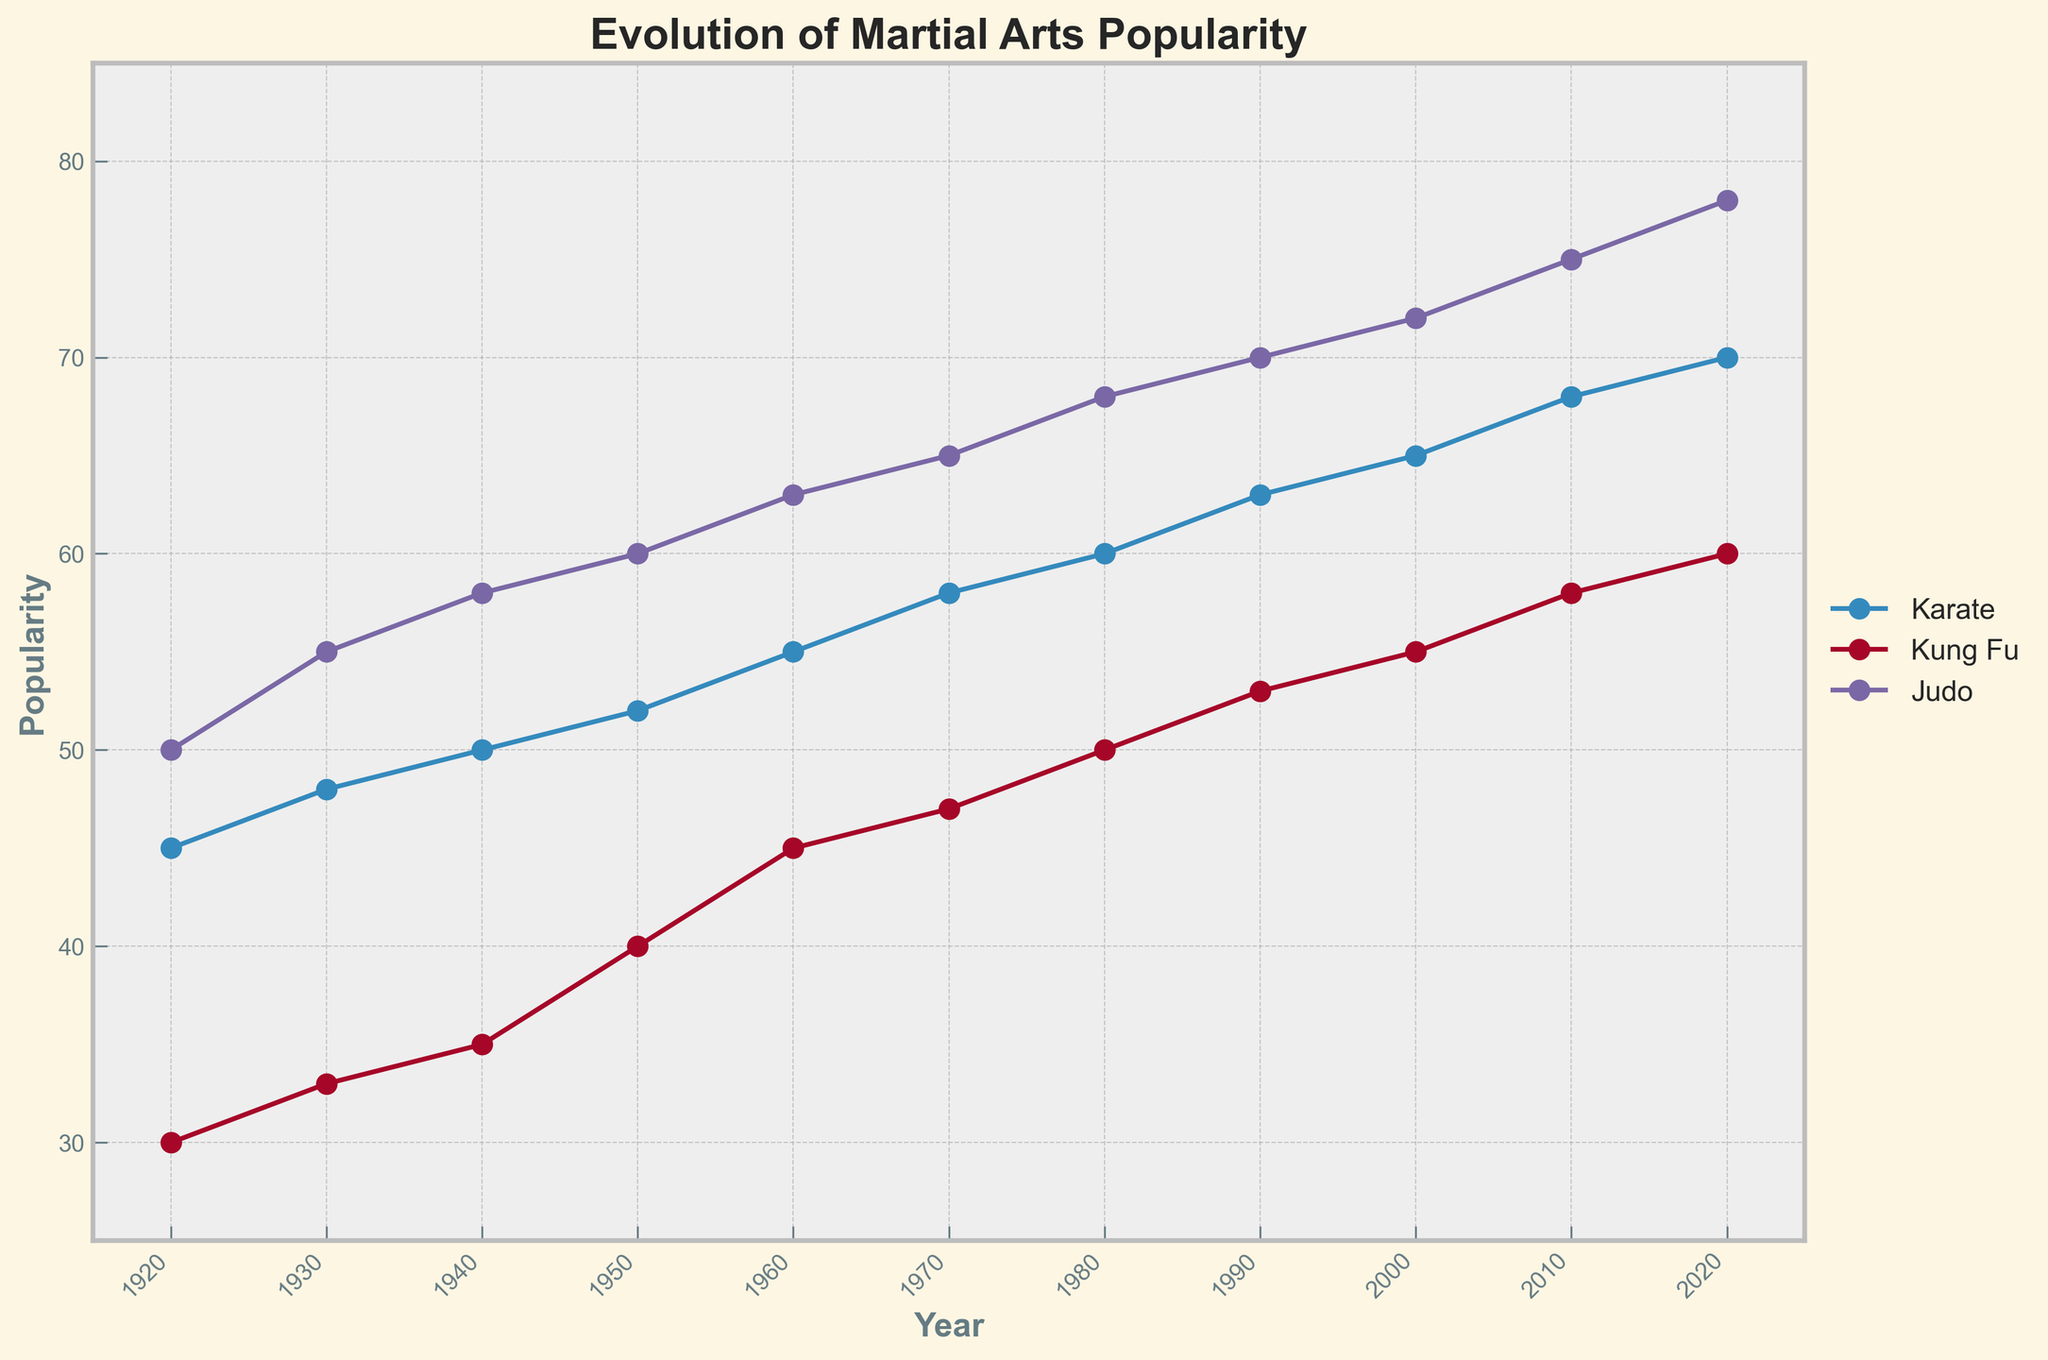What is the title of the plot? The title of the plot is located at the top and is a central, bold text. In the provided plot, the title is "Evolution of Martial Arts Popularity".
Answer: Evolution of Martial Arts Popularity Which martial art had the highest popularity in 2020? To find this, locate the year 2020 on the x-axis and identify the martial arts plotted for that year. Then, compare their popularity values. Judo (Kodokan) has the highest popularity with a value of 78.
Answer: Judo (Kodokan) How many different martial arts styles are represented in the year 1960? Look at the year 1960 along the x-axis and count the different markers representing different martial arts styles. There are three distinct styles: Karate (Kyokushin), Kung Fu (Baguazhang), and Judo (Kodokan).
Answer: Three Which martial art showed the greatest increase in popularity between 2000 and 2010? Compare the popularity values of all martial arts from 2000 to 2010. The difference in Judo (Kodokan) is (75 - 72) = 3, Karate (Shito-Ryu) is (68 - 65) = 3, and Kung Fu (Jeet Kune Do to Sanda) decreased. So the increase is the same for Judo and Karate.
Answer: Judo (Kodokan) and Karate (Shito-Ryu) What is the overall trend of judo's popularity from 1920 to 2020? To analyze the trend, track the popularity values for judo across the years. The data points show a consistently increasing trend from 50 in 1920 to 78 in 2020.
Answer: Increasing By how much did Karate (Shotokan) increase in popularity between 1920 and 1940? Look at the popularity values for Karate (Shotokan) in 1920 and 1940. The values are 45 and 50, respectively. The increase is 50 - 45 = 5.
Answer: 5 Which martial art saw a continuous rise in popularity across all data points from 1920 to 2020? Check each martial art's trend line from 1920 to 2020. Judo's (Kodokan) popularity continuously rises from 50 in 1920 to 78 in 2020.
Answer: Judo (Kodokan) At which point in time did Kung Fu's represented styles see the highest combined popularity? Add the popularity values for all Kung Fu styles at each decade. In 2010, the combined popularity of Kung Fu (Sanda) is 58, which is the highest among all specified years.
Answer: 2010 What was the popularity change for Kung Fu from 1980 to 1990? Find the popularity values for Kung Fu in 1980 and 1990. The values are 50 in 1980 (Jeet Kune Do) and 53 in 1990 (Jeet Kune Do). The change is 53 - 50 = 3.
Answer: 3 Which martial art had the highest overall popularity over all decades combined, and what was the combined total? Sum up all popularity scores for each martial art across all years. Judo's combined total is highest: 50+55+58+60+63+65+68+70+72+75+78 = 684.
Answer: Judo (Kodokan), 684 